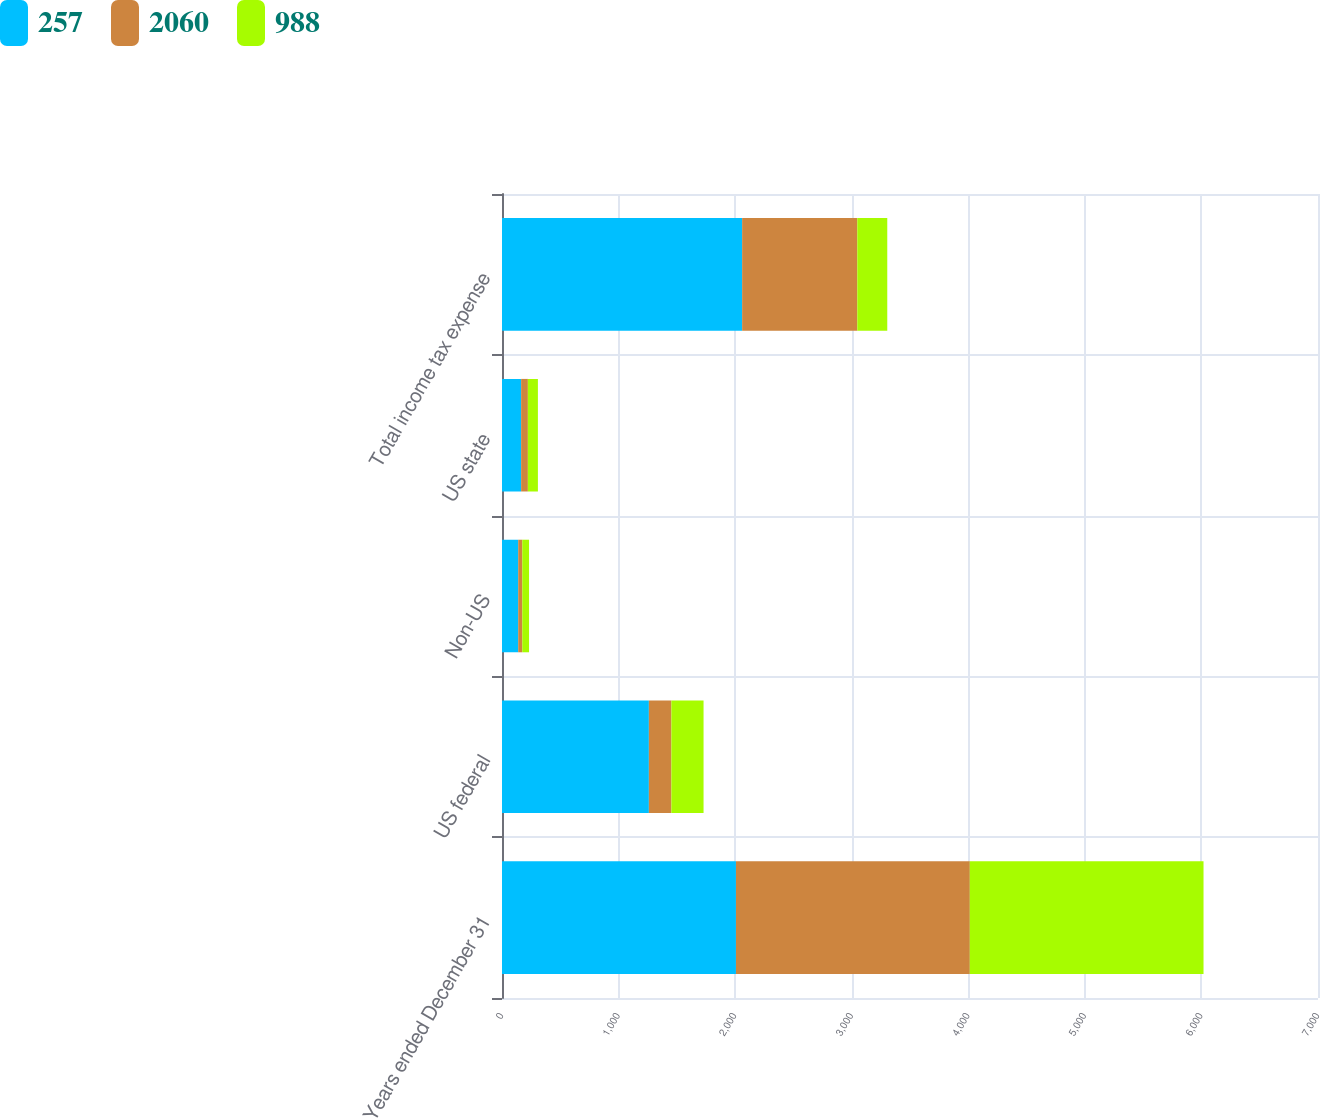Convert chart. <chart><loc_0><loc_0><loc_500><loc_500><stacked_bar_chart><ecel><fcel>Years ended December 31<fcel>US federal<fcel>Non-US<fcel>US state<fcel>Total income tax expense<nl><fcel>257<fcel>2007<fcel>1260<fcel>139<fcel>164<fcel>2060<nl><fcel>2060<fcel>2006<fcel>193<fcel>35<fcel>58<fcel>988<nl><fcel>988<fcel>2005<fcel>276<fcel>58<fcel>86<fcel>257<nl></chart> 